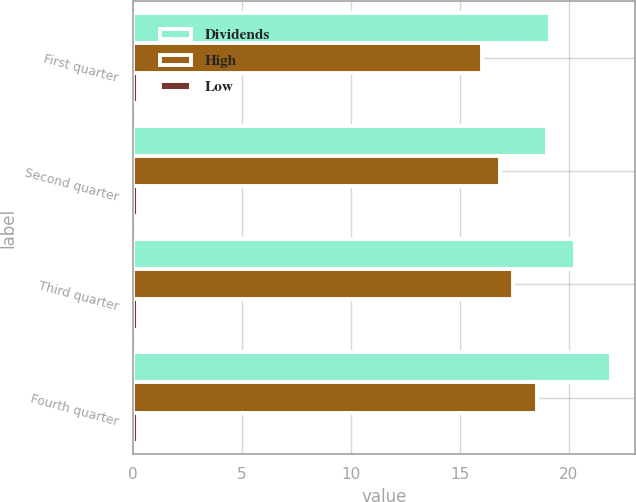Convert chart. <chart><loc_0><loc_0><loc_500><loc_500><stacked_bar_chart><ecel><fcel>First quarter<fcel>Second quarter<fcel>Third quarter<fcel>Fourth quarter<nl><fcel>Dividends<fcel>19.13<fcel>18.98<fcel>20.29<fcel>21.94<nl><fcel>High<fcel>16.01<fcel>16.83<fcel>17.44<fcel>18.53<nl><fcel>Low<fcel>0.24<fcel>0.24<fcel>0.24<fcel>0.24<nl></chart> 